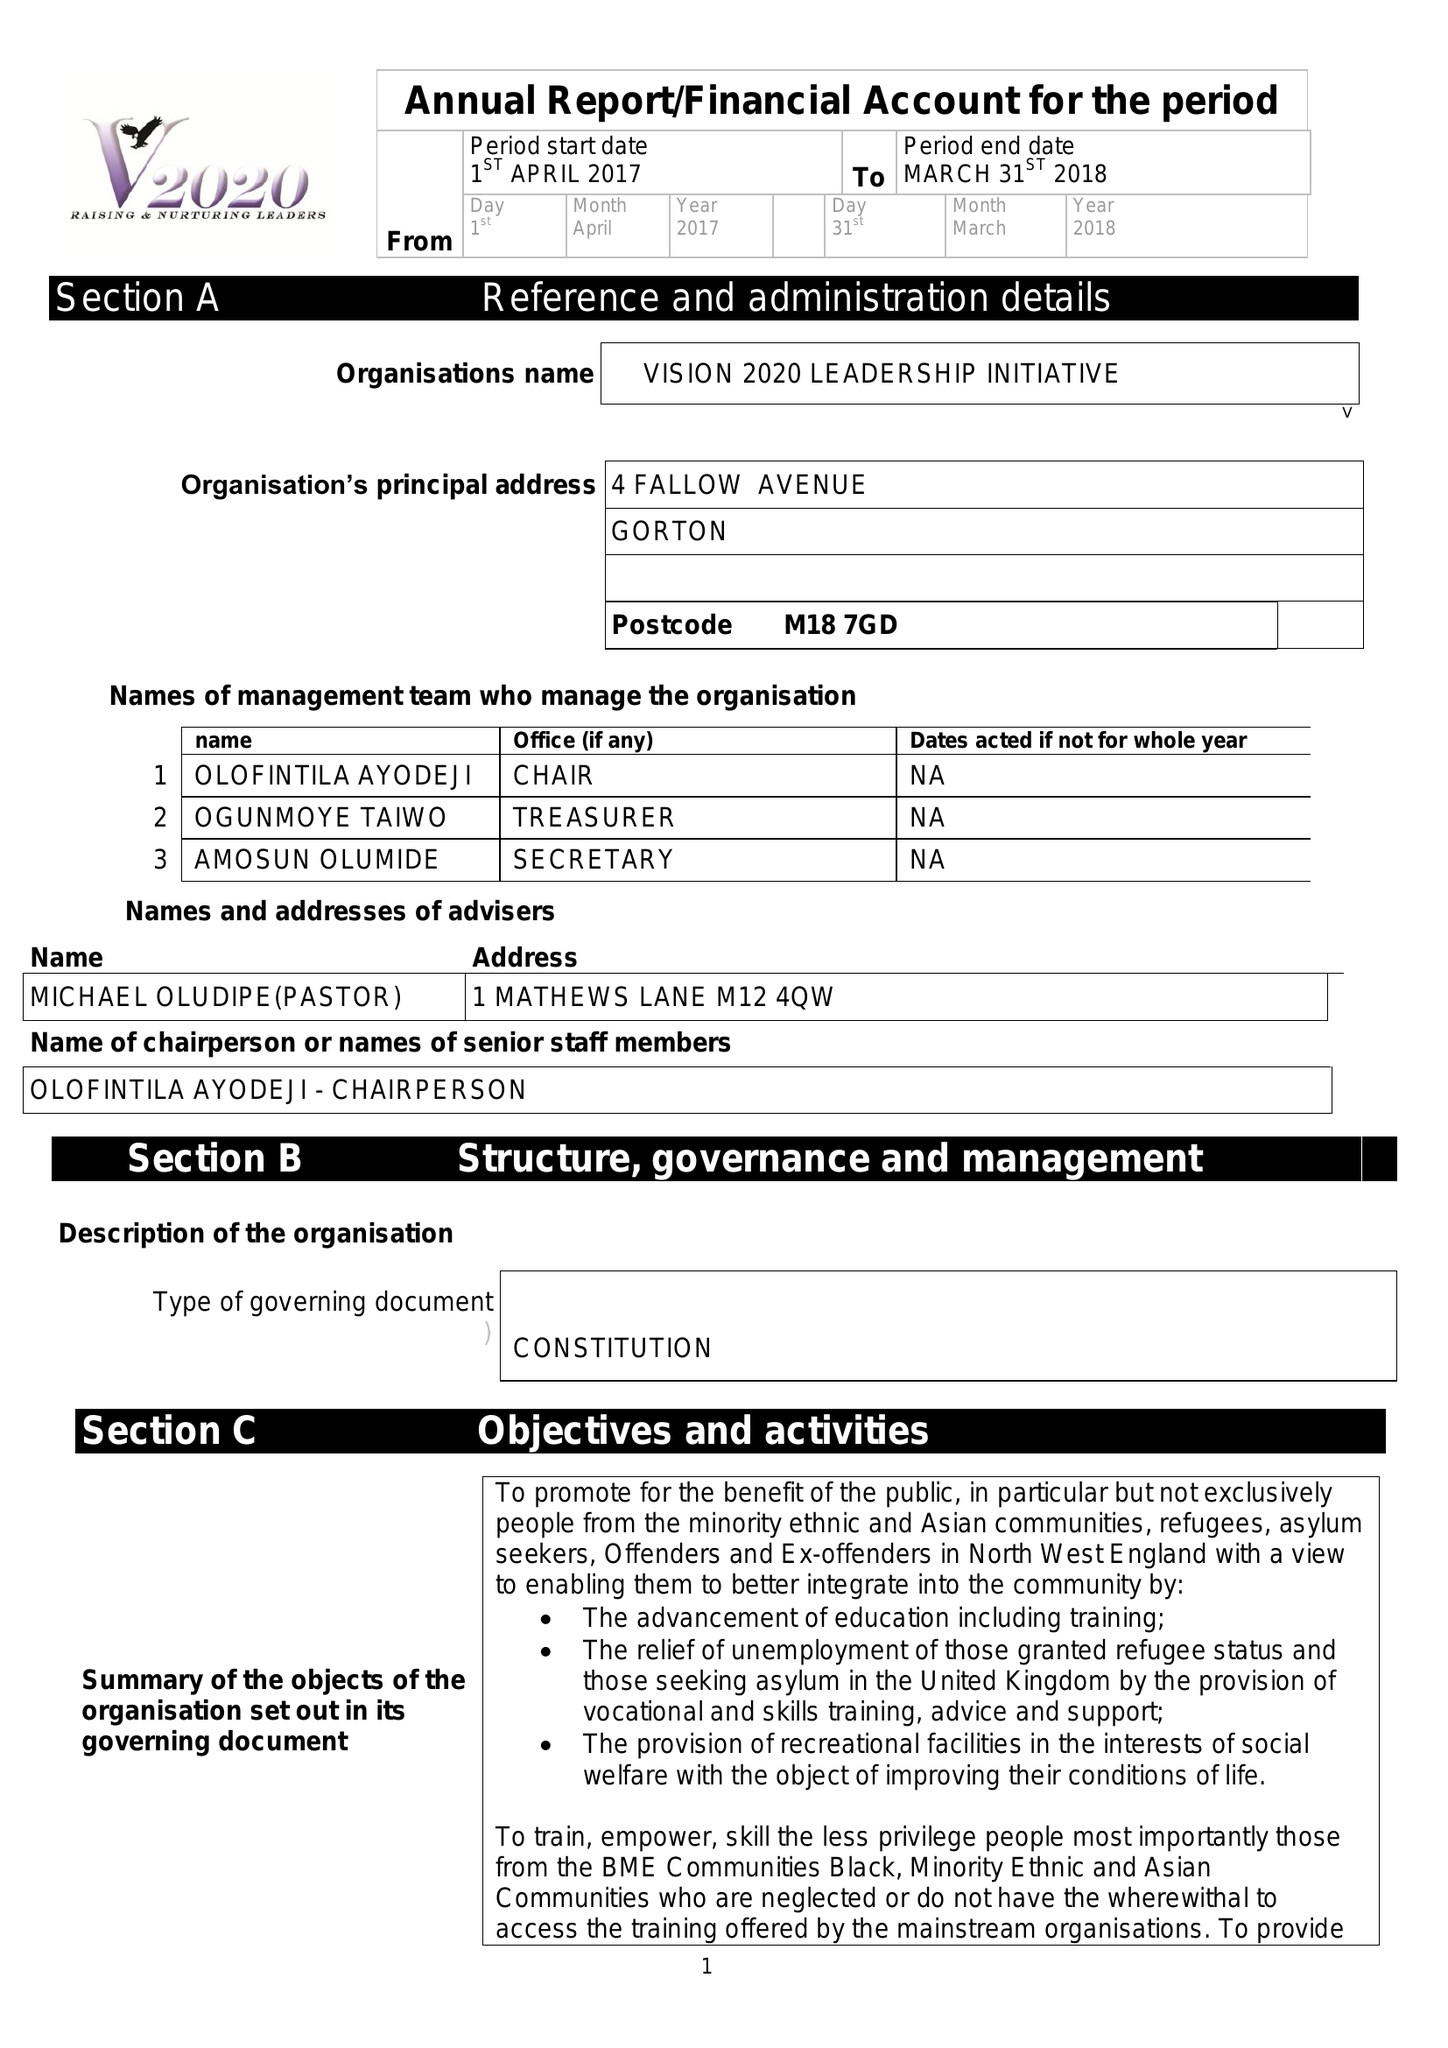What is the value for the spending_annually_in_british_pounds?
Answer the question using a single word or phrase. 30100.00 